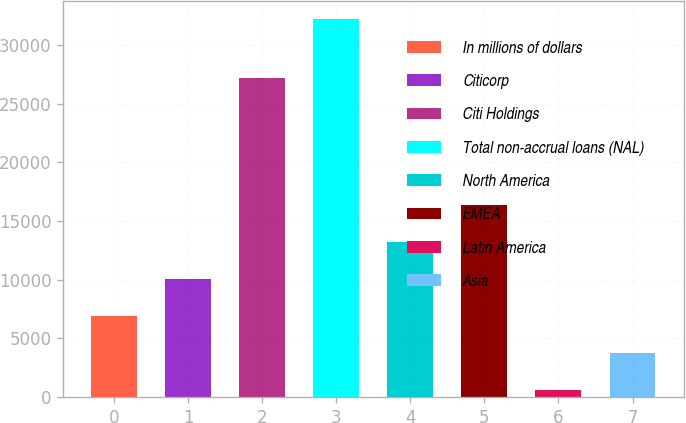Convert chart to OTSL. <chart><loc_0><loc_0><loc_500><loc_500><bar_chart><fcel>In millions of dollars<fcel>Citicorp<fcel>Citi Holdings<fcel>Total non-accrual loans (NAL)<fcel>North America<fcel>EMEA<fcel>Latin America<fcel>Asia<nl><fcel>6892<fcel>10053.5<fcel>27216<fcel>32184<fcel>13215<fcel>16376.5<fcel>569<fcel>3730.5<nl></chart> 